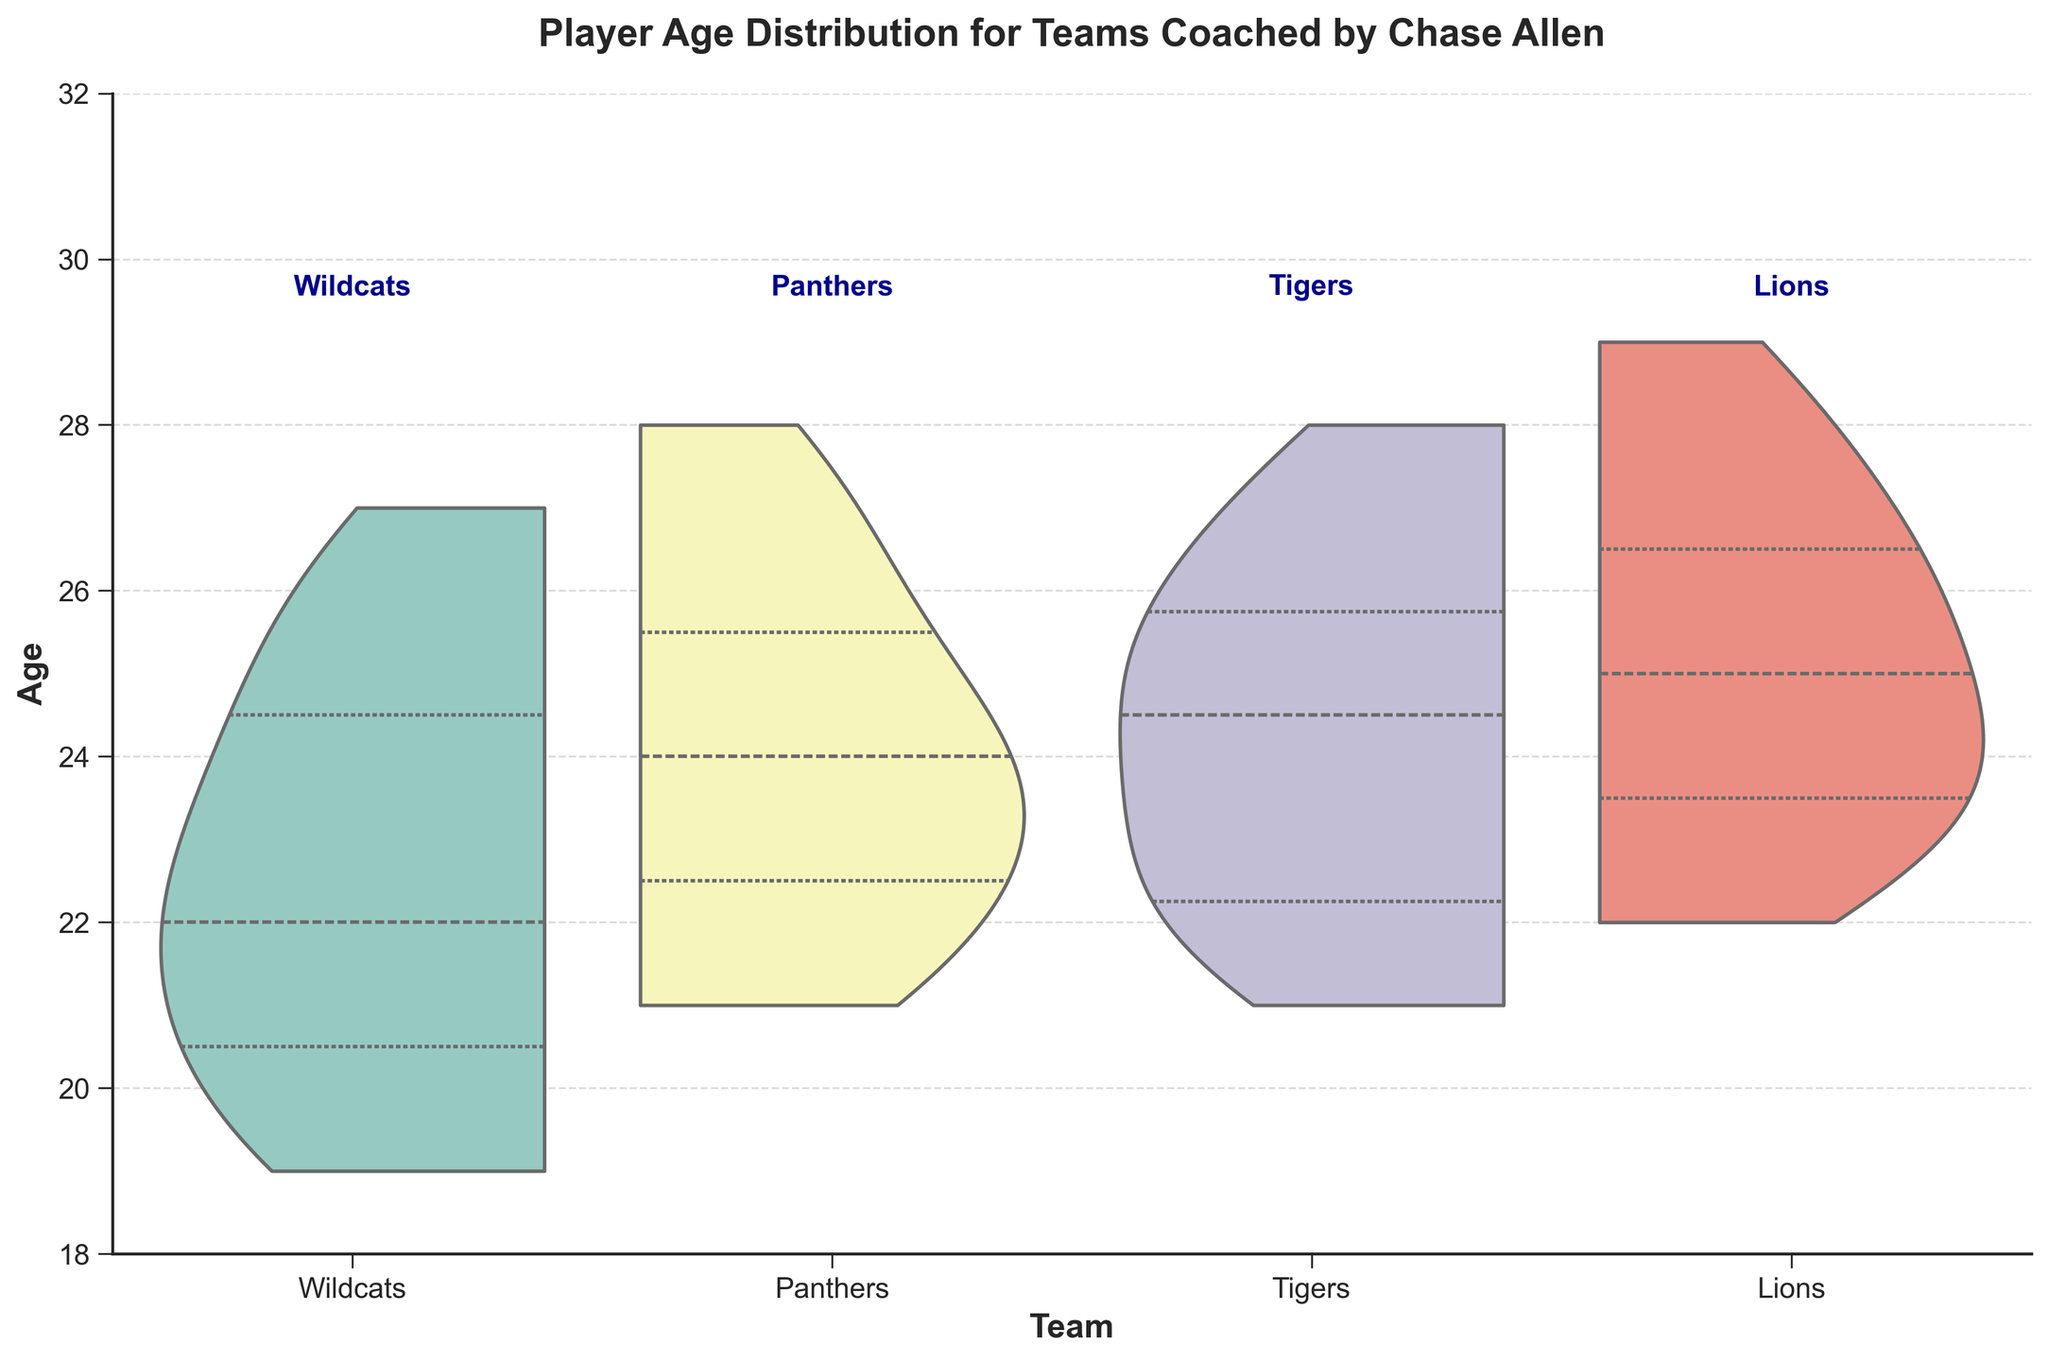What's the title of the figure? The title is located at the top of the figure and describes the overall theme of the plot.
Answer: Player Age Distribution for Teams Coached by Chase Allen Which team has the highest median age? The median age for each team is indicated by the line within the thickest part of the violin plot.
Answer: Lions What is the age range for the Wildcats team? The age range can be determined by looking at the upper and lower bounds of the violin plot for the Wildcats.
Answer: 19 to 27 How do the age distributions of the Wildcats and Panthers compare? Comparing the thickness and spread of the violin plots of the Wildcats and Panthers shows that the Wildcats' distribution is slightly broader, while the Panthers' distribution is more concentrated around 23-26 years.
Answer: Wildcats have a broader age range, Panthers are more concentrated Which team has the youngest player? The youngest player is found at the bottom of the lowest point of the violin plots.
Answer: Wildcats What is the most common age range for the Tigers? The most common age range can be inferred by looking at the thickest part of the violin plot for the Tigers.
Answer: 22 to 26 Are there any significant differences in age distribution between the Tigers and Lions? Comparing the Tigers and Lions' violin plots: Tigers show a somewhat uniform distribution, while Lions show a cluster around 23-26 years, with less spread than the Tigers.
Answer: Yes, Tigers have a more uniform distribution, while Lions have a cluster Which team has the oldest player? The oldest player is located at the top of the highest point of any violin plot.
Answer: Lions How does the age distribution of the Panthers compare to the Lions? The Panthers' distribution is more spread out from 21 to 28 while the Lions are more concentrated around higher ages, specifically 23 to 28.
Answer: Panthers are more spread out, Lions are more concentrated higher What is the median age for the Wildcats? The median age is the value that divides the violin plot into two equal parts, indicated by a central line in the busiest section of the Wildcats' plot.
Answer: 22 